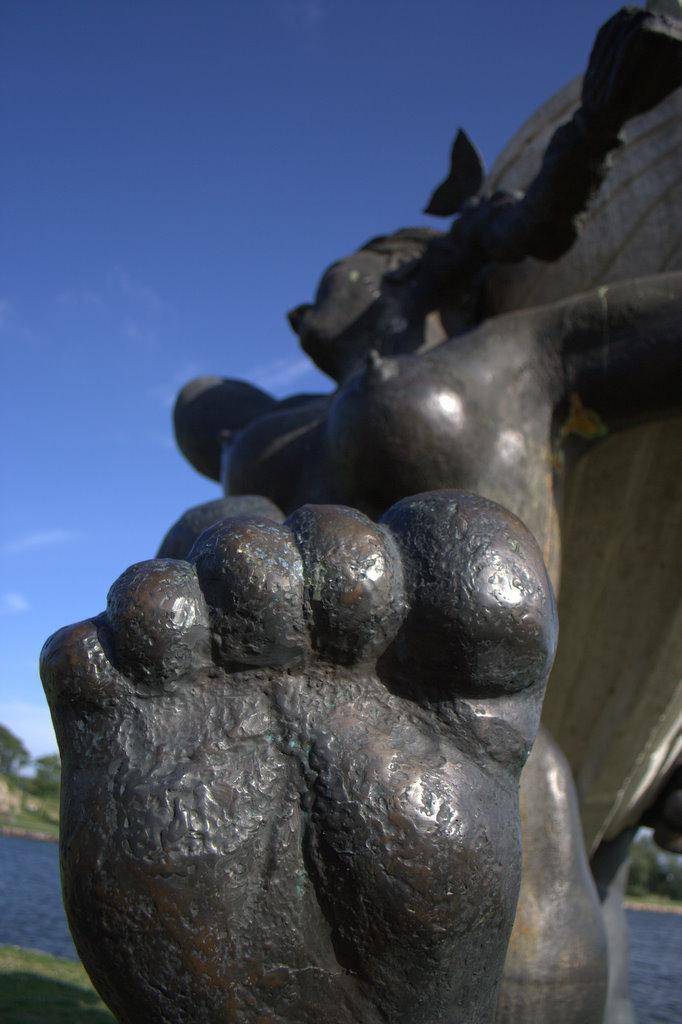Could you give a brief overview of what you see in this image? In this image we can see a statue. On the top of the image we can see the sky. On the left bottom of the image we can see water body. 